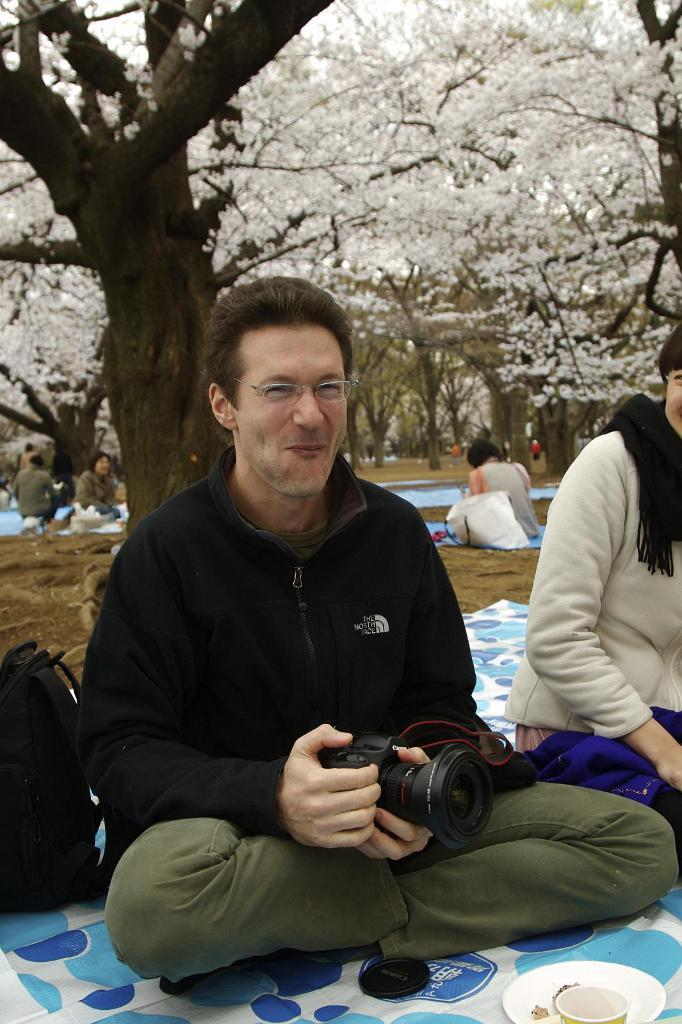What are the people in the image doing? The persons in the image are sitting on the floor. Can you describe the man in the image? The man in the image is holding a camera. What can be seen in the background of the image? Trees and grass are visible in the background of the image. What type of pets are sitting with the persons in the image? There are no pets visible in the image; only the persons sitting on the floor are present. 